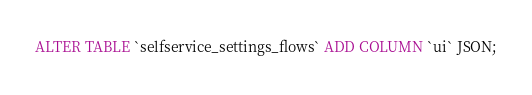<code> <loc_0><loc_0><loc_500><loc_500><_SQL_>ALTER TABLE `selfservice_settings_flows` ADD COLUMN `ui` JSON;</code> 